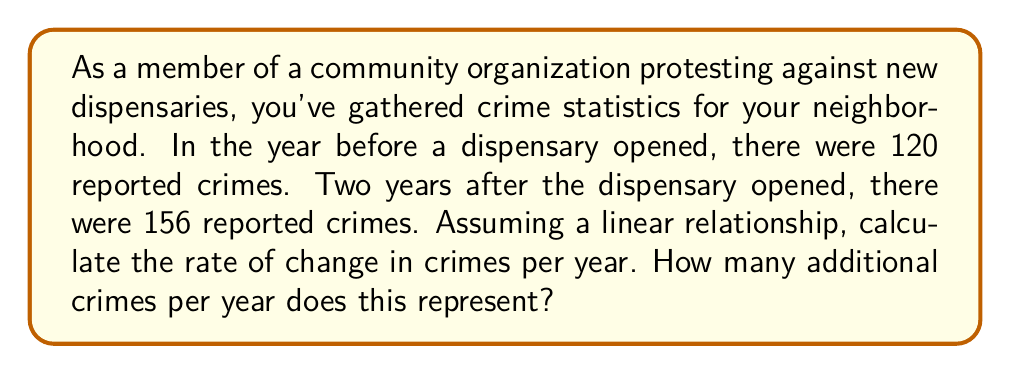Can you answer this question? To solve this problem, we'll use the rate of change formula:

$$ \text{Rate of Change} = \frac{\text{Change in y}}{\text{Change in x}} $$

Where y represents the number of crimes and x represents the time in years.

1. Identify the given information:
   * Initial number of crimes (y1) = 120
   * Final number of crimes (y2) = 156
   * Time interval (x2 - x1) = 2 years

2. Calculate the change in y (number of crimes):
   $$ \Delta y = y_2 - y_1 = 156 - 120 = 36 $$

3. Apply the rate of change formula:
   $$ \text{Rate of Change} = \frac{\Delta y}{\Delta x} = \frac{36}{2} = 18 $$

The rate of change is 18 crimes per year.

To find how many additional crimes this represents per year, we simply use the calculated rate of change, which is already in the form of crimes per year.
Answer: The rate of change is 18 crimes per year, representing an increase of 18 additional crimes per year. 